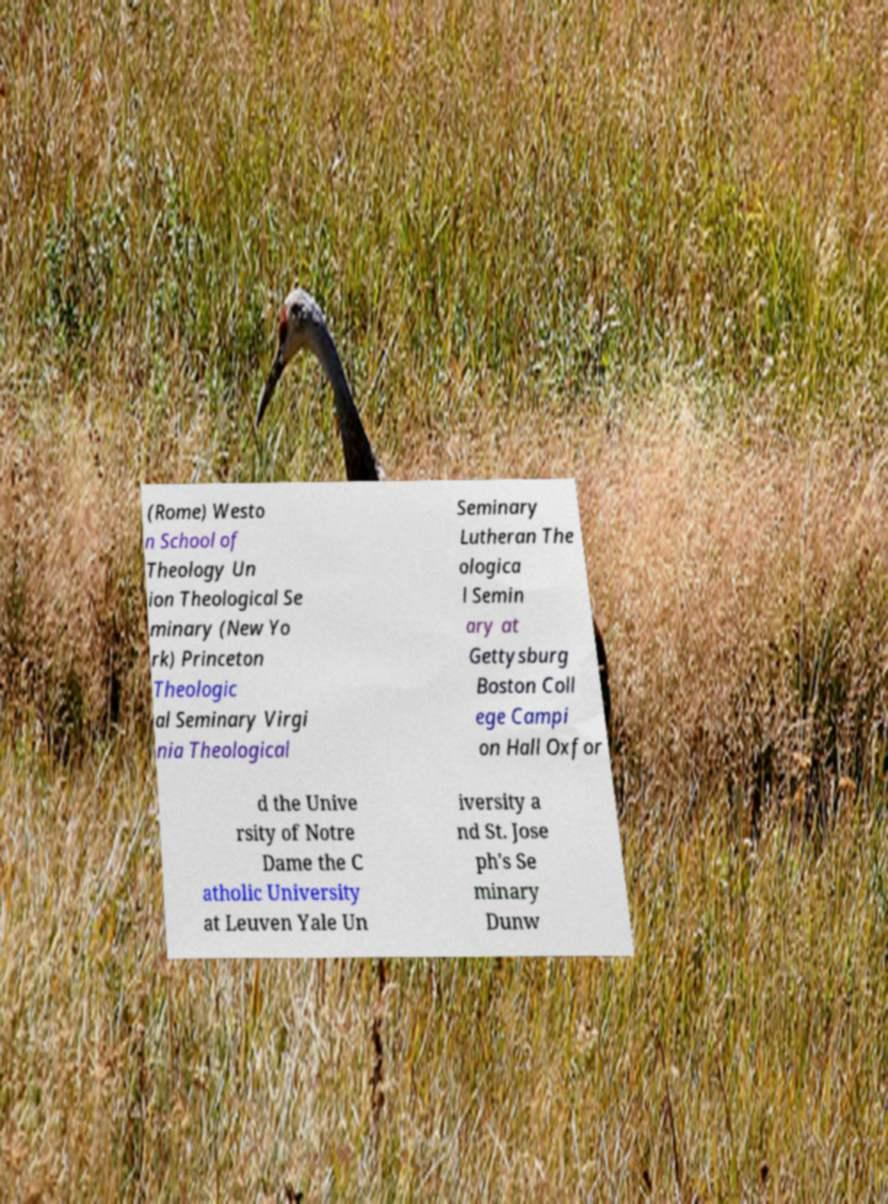Could you assist in decoding the text presented in this image and type it out clearly? (Rome) Westo n School of Theology Un ion Theological Se minary (New Yo rk) Princeton Theologic al Seminary Virgi nia Theological Seminary Lutheran The ologica l Semin ary at Gettysburg Boston Coll ege Campi on Hall Oxfor d the Unive rsity of Notre Dame the C atholic University at Leuven Yale Un iversity a nd St. Jose ph's Se minary Dunw 